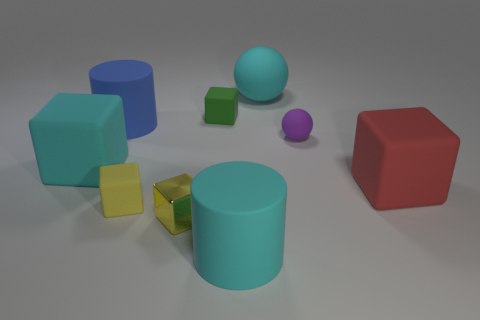Subtract all cyan blocks. How many blocks are left? 4 Subtract all blue cubes. Subtract all purple spheres. How many cubes are left? 5 Add 1 large cyan spheres. How many objects exist? 10 Subtract all cylinders. How many objects are left? 7 Add 4 small metal things. How many small metal things are left? 5 Add 9 large cyan cylinders. How many large cyan cylinders exist? 10 Subtract 1 red blocks. How many objects are left? 8 Subtract all small yellow shiny objects. Subtract all cylinders. How many objects are left? 6 